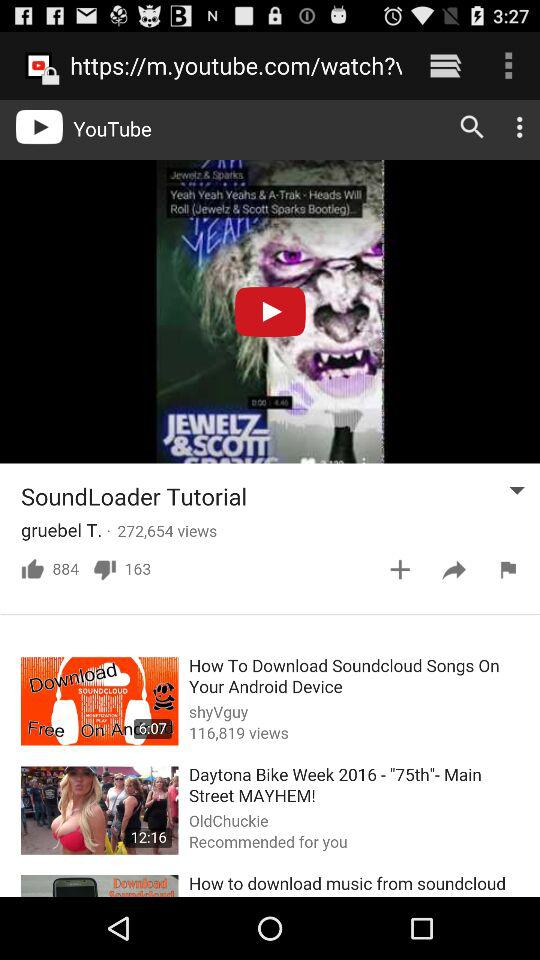How many views are there of the "SoundLoader Tutorial"? There are 272,654 views of the "SoundLoader Tutorial". 